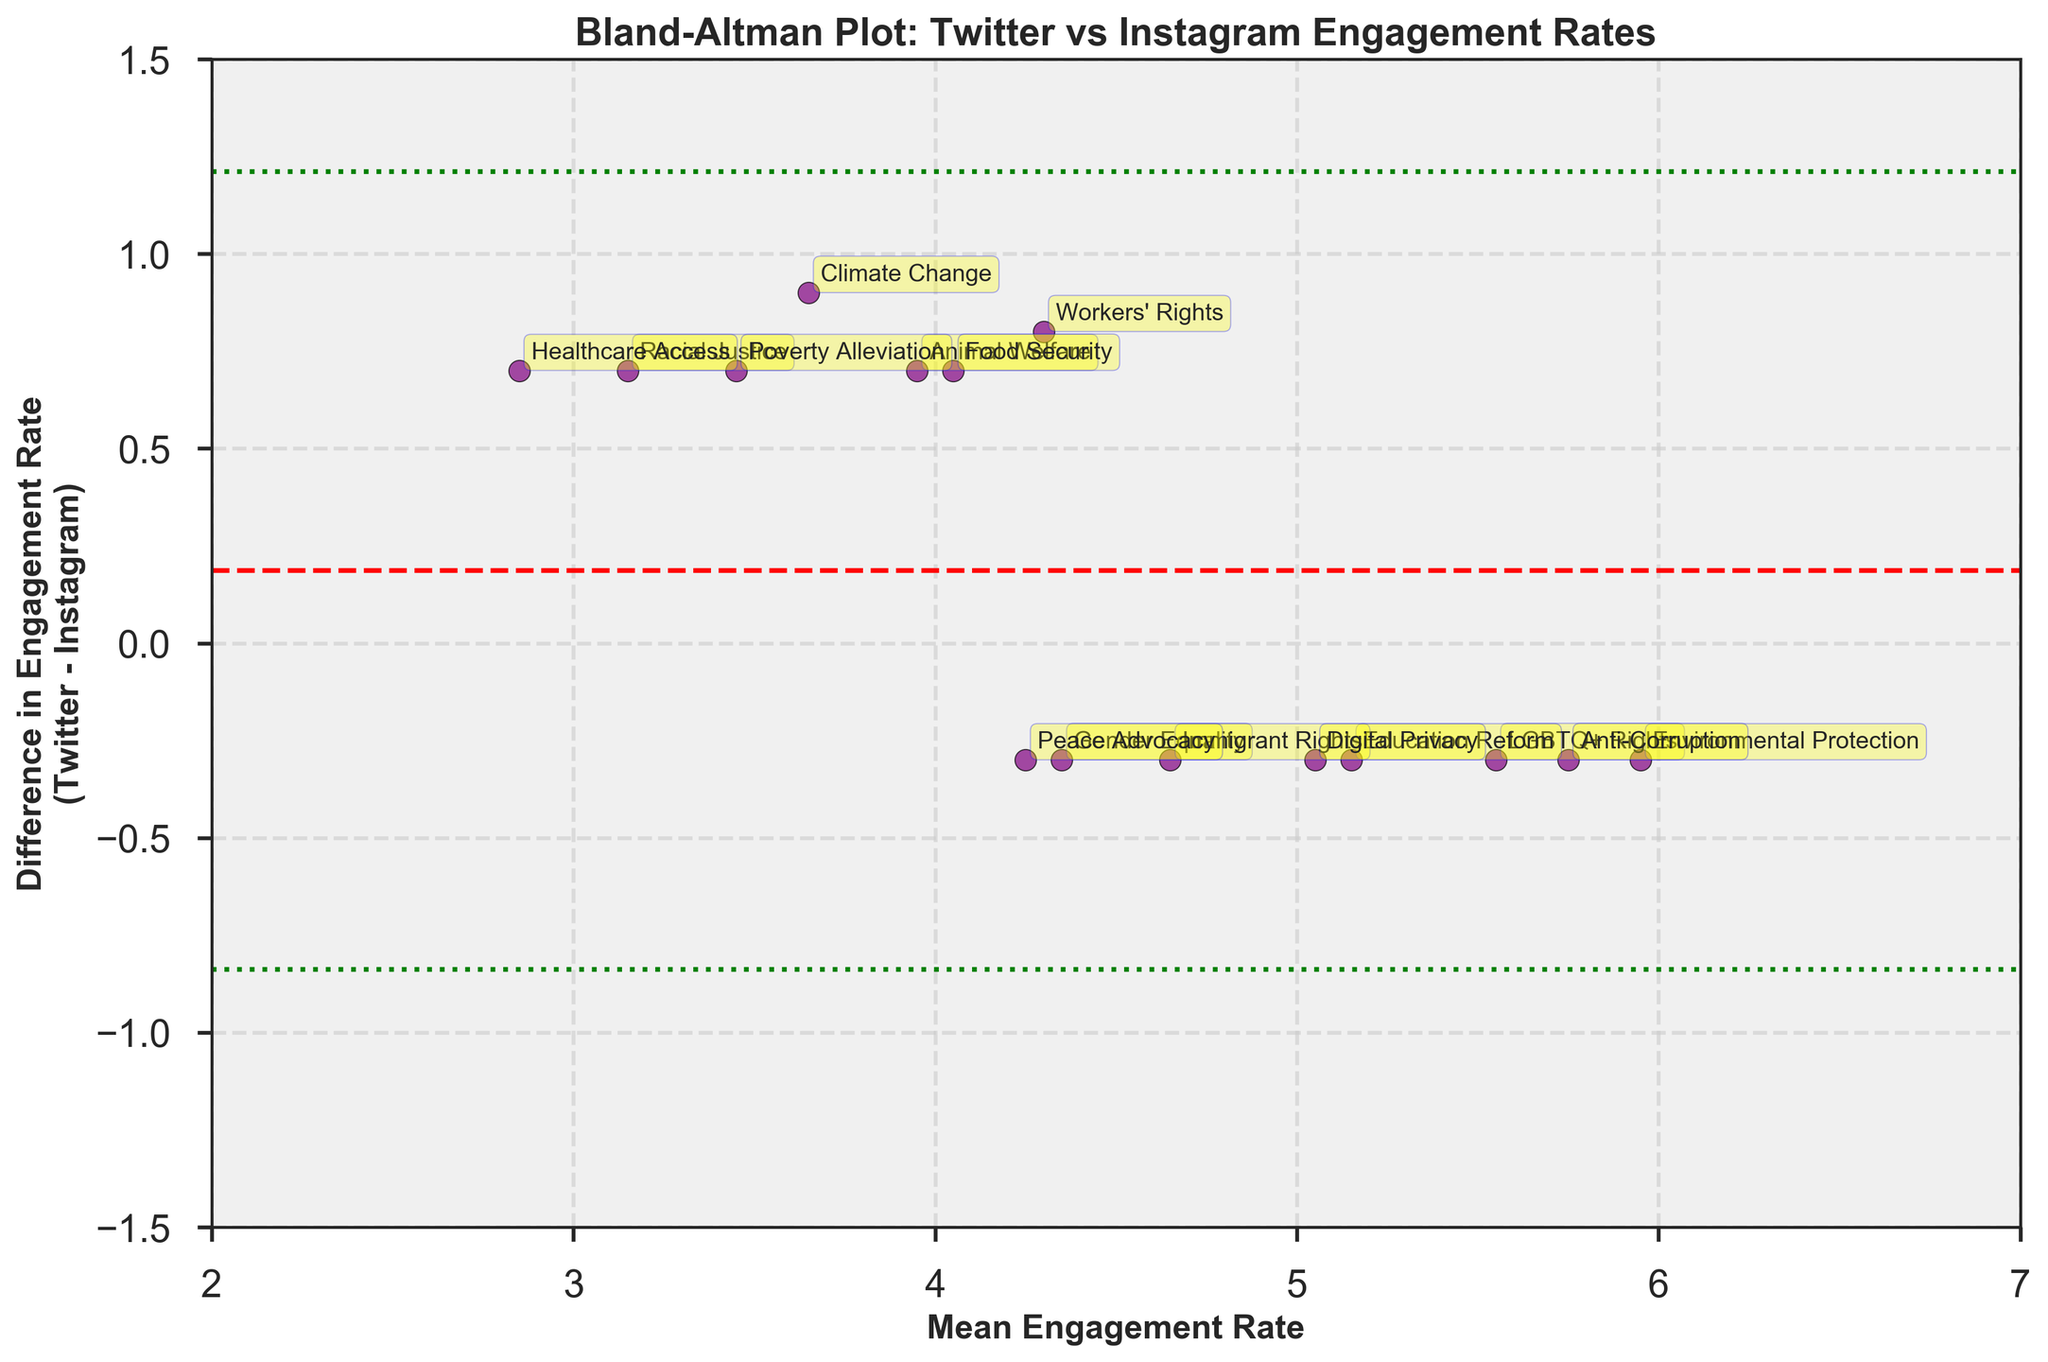What is the title of the plot? The title is displayed at the top of the plot, typically in a larger font to grab attention. The key phrases in the title indicate what the plot is about.
Answer: Bland-Altman Plot: Twitter vs Instagram Engagement Rates How many horizontal reference lines are in the plot? To answer this, visually count the lines that span the plot horizontally. These lines help in interpreting the data differences.
Answer: Three What is the color of the data points? Observing the dots on the plot and noting their color will answer this question. The color often helps in differentiating data points visually.
Answer: Purple What is the range of the y-axis for differences in engagement rates? The y-axis is labeled "Difference in Engagement Rate" and viewing the scale on the side can help determine the range of values.
Answer: -1.5 to 1.5 What is the mean difference in engagement rates between the two platforms? The mean difference can be found by looking for the horizontal dashed red line in the plot and noting its y-coordinate.
Answer: 0.1 Which campaign type has the highest mean engagement rate? Locate the data points, note their positions on the x-axis (which represents the mean engagement rate), and identify the point farthest to the right, then read the annotation.
Answer: Environmental Protection How many data points have a positive difference? Count the data points that lie above the horizontal axis (difference = 0) to determine how many differences are positive.
Answer: Six What does a positive difference in engagement rates mean in this plot? Recall the y-axis label and interpret what a positive value indicates about the engagement rates between the two platforms. A positive difference means the engagement rate on Twitter is higher than on Instagram.
Answer: Engagement rate on Twitter is higher than on Instagram Which campaign types show a negative difference in engagement rates? Identify the data points below the horizontal line (difference = 0), and read their annotations to determine the campaigns.
Answer: LGBTQ+ Rights, Gender Equality, Environmental Protection, Education Reform, Immigrant Rights, Anti-Corruption, Peace Advocacy, Digital Privacy What are the upper and lower limits of agreement in this plot? These are the green dotted lines above and below the mean difference line. Their y-coordinates can be noted directly from the plot.
Answer: 1.3 and -1.1 